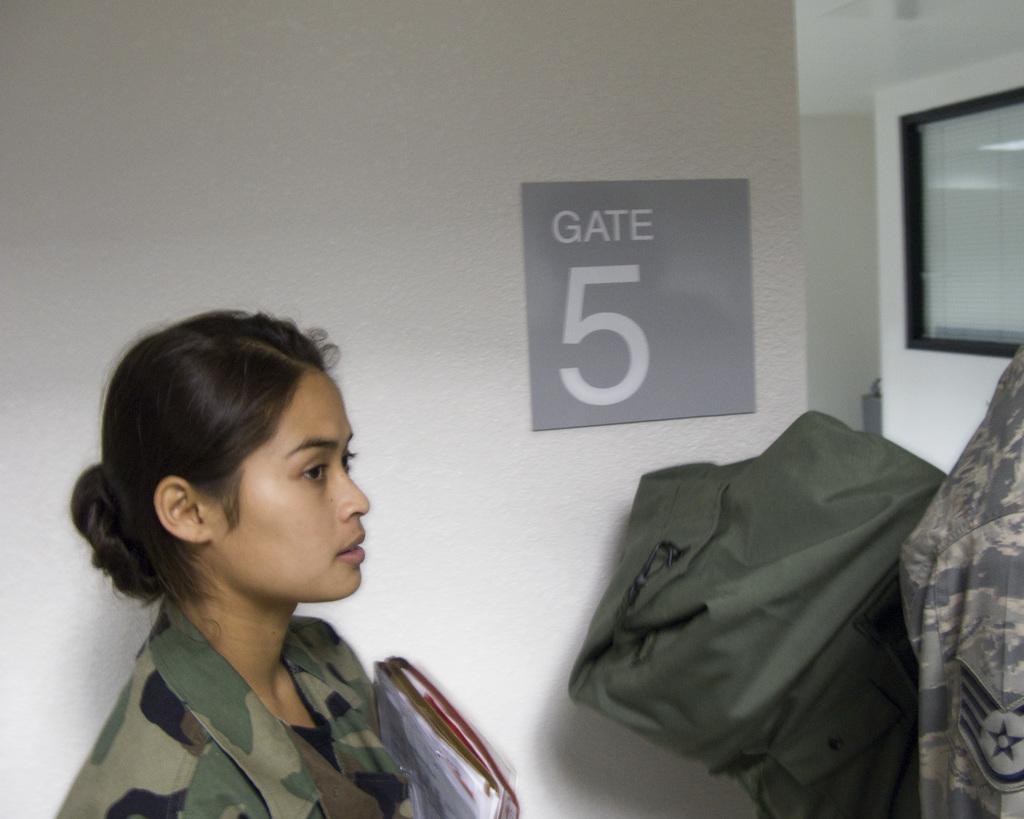How would you summarize this image in a sentence or two? In the picture we can see a woman in an army dress and she is holding some files and in front of her we can see a green color bag and a part of army dress and beside her we can see a wall with a board and mentioned as gate 5 in it and beside it we can see a wall with a part of the glass to it. 